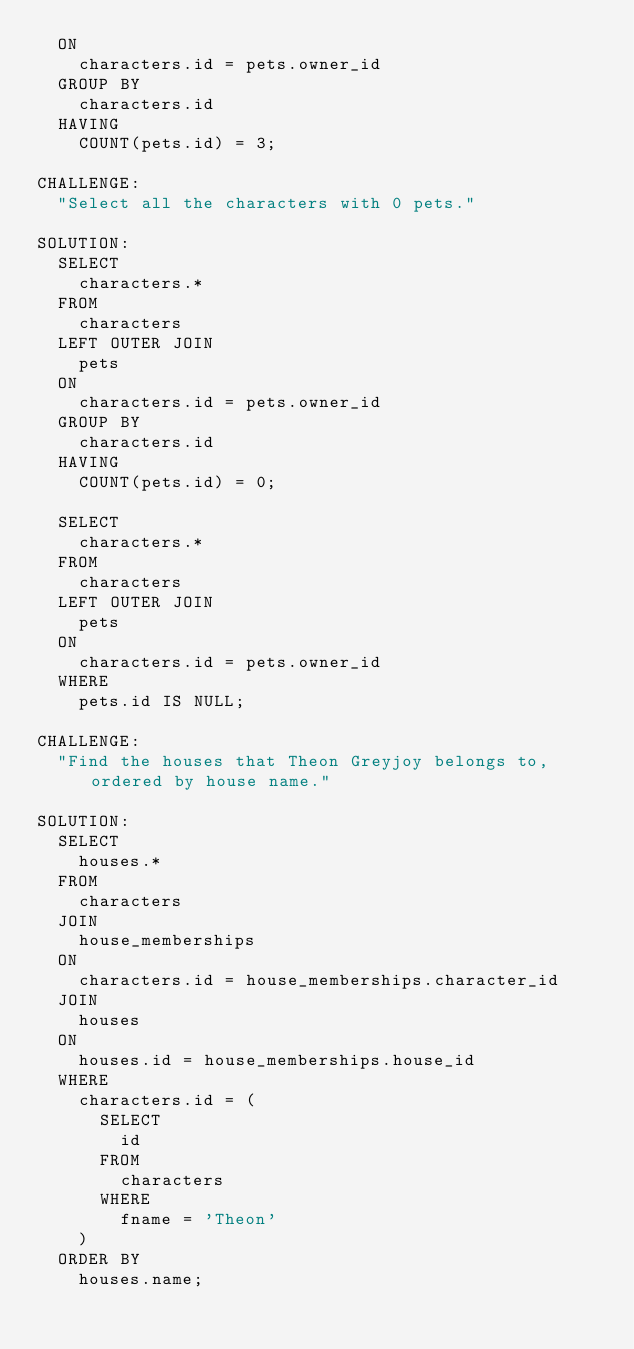Convert code to text. <code><loc_0><loc_0><loc_500><loc_500><_SQL_>  ON
    characters.id = pets.owner_id
  GROUP BY
    characters.id
  HAVING
    COUNT(pets.id) = 3;

CHALLENGE:
  "Select all the characters with 0 pets."

SOLUTION:
  SELECT
    characters.*
  FROM
    characters
  LEFT OUTER JOIN
    pets
  ON
    characters.id = pets.owner_id
  GROUP BY
    characters.id
  HAVING
    COUNT(pets.id) = 0;

  SELECT
    characters.*
  FROM
    characters
  LEFT OUTER JOIN
    pets
  ON
    characters.id = pets.owner_id
  WHERE
    pets.id IS NULL;

CHALLENGE:
  "Find the houses that Theon Greyjoy belongs to, ordered by house name."

SOLUTION:
  SELECT
    houses.*
  FROM
    characters
  JOIN
    house_memberships
  ON
    characters.id = house_memberships.character_id
  JOIN
    houses
  ON
    houses.id = house_memberships.house_id
  WHERE
    characters.id = (
      SELECT
        id
      FROM
        characters
      WHERE
        fname = 'Theon'
    )
  ORDER BY
    houses.name;
</code> 